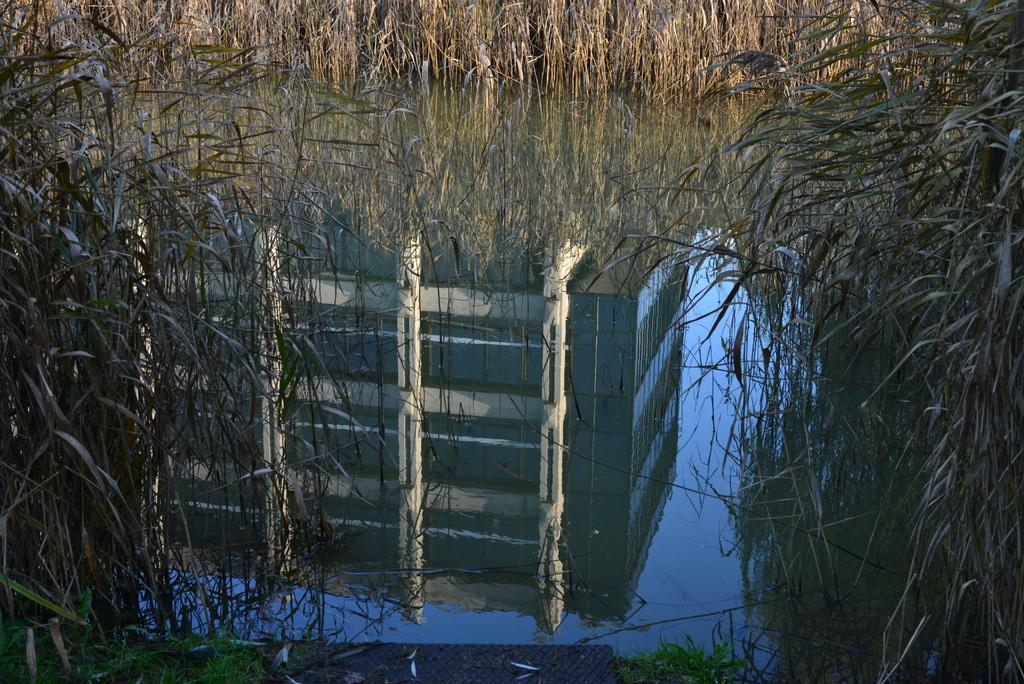What type of living organisms can be seen in the image? Plants can be seen in the image. What is the primary element in the image? There is water in the image. What can be observed on the surface of the water? The reflection of a building is visible on the water. What type of insect can be seen crawling on the string in the image? There is no insect or string present in the image. 